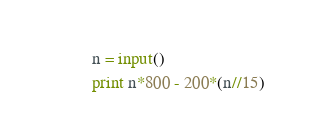Convert code to text. <code><loc_0><loc_0><loc_500><loc_500><_Python_>n = input()
print n*800 - 200*(n//15)</code> 